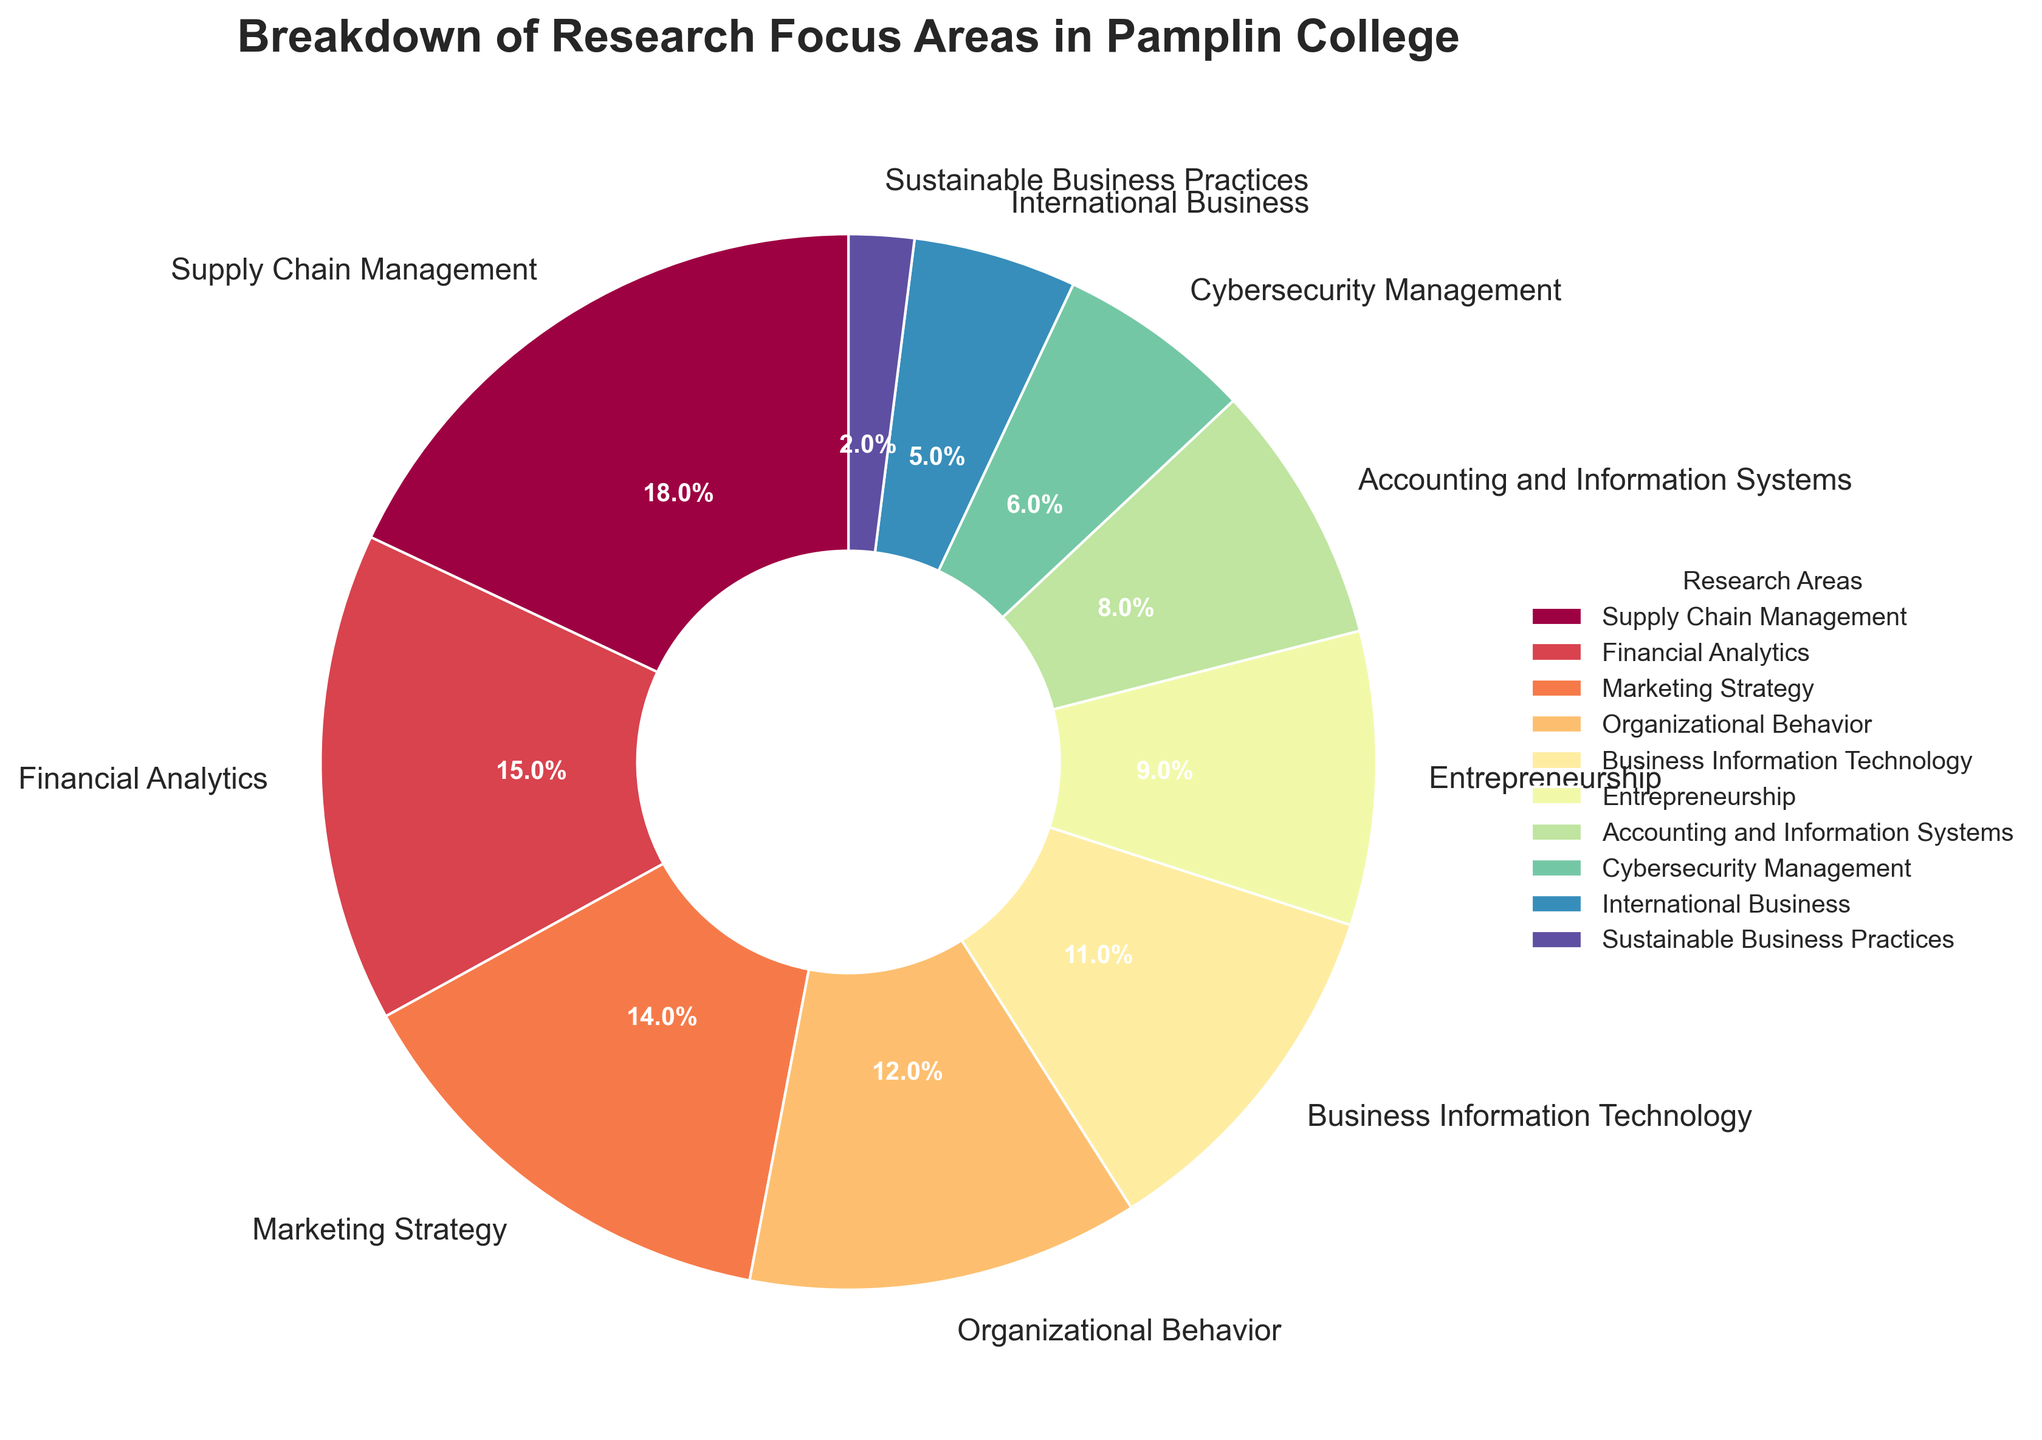Which research area has the highest percentage of academic publications? To find the research area with the highest percentage, look at the segments of the pie chart and identify the largest segment. The largest segment is for Supply Chain Management.
Answer: Supply Chain Management How does the percentage of publications in Cybersecurity Management compare to that in Sustainable Business Practices? Look at the segments corresponding to Cybersecurity Management and Sustainable Business Practices. Cybersecurity Management has a larger percentage than Sustainable Business Practices. Cybersecurity Management is at 6% while Sustainable Business Practices is at 2%.
Answer: Cybersecurity Management has a higher percentage What's the combined percentage of academic publications in Financial Analytics and Marketing Strategy? Add the percentages for Financial Analytics (15%) and Marketing Strategy (14%). The total is 15 + 14 = 29%.
Answer: 29% What is the difference in publication percentage between the area with the highest and the area with the lowest focus? Identify the highest and lowest percentages. Supply Chain Management is the highest with 18%, and Sustainable Business Practices is the lowest with 2%. The difference is 18 - 2 = 16%.
Answer: 16% Which research areas have publication percentages less than 10%? Identify segments that are less than 10%. Entrepreneurship (9%), Accounting and Information Systems (8%), Cybersecurity Management (6%), International Business (5%), and Sustainable Business Practices (2%) are all below 10%.
Answer: Entrepreneurship, Accounting and Information Systems, Cybersecurity Management, International Business, Sustainable Business Practices How many research areas have a publication percentage greater than or equal to 15%? Identify and count the segments with percentages 15% or greater. Supply Chain Management (18%) and Financial Analytics (15%) meet the criteria. There are 2 such areas.
Answer: 2 What is the difference in the publication percentage between Business Information Technology and Organizational Behavior? Find the percentages for Business Information Technology (11%) and Organizational Behavior (12%). The difference is 12 - 11 = 1%.
Answer: 1% What percentage of academic publications is in Marketing Strategy if combined with Supply Chain Management and Business Information Technology? Add the percentages for Marketing Strategy (14%), Supply Chain Management (18%), and Business Information Technology (11%). The total is 14 + 18 + 11 = 43%.
Answer: 43% Which research area is closest in publication percentage to Accounting and Information Systems? Identify the segment closest to 8%. Cybersecurity Management with 6% is the closest.
Answer: Cybersecurity Management What is the total percentage of academic publications within the top three research focuses? Add the percentages of the top three areas: Supply Chain Management (18%), Financial Analytics (15%), and Marketing Strategy (14%). The total is 18 + 15 + 14 = 47%.
Answer: 47% 